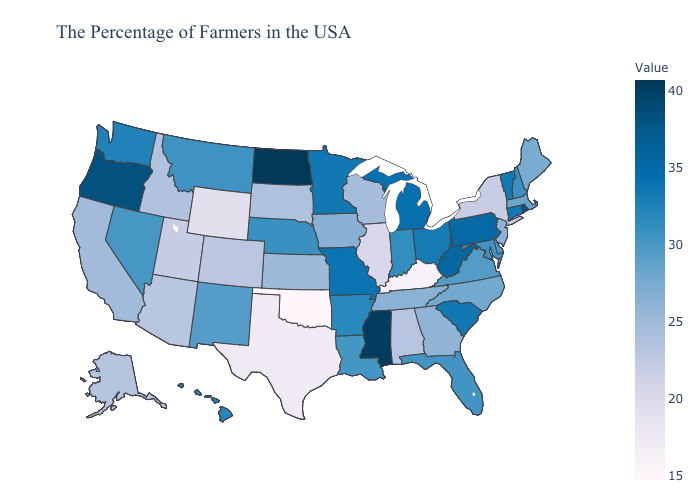Does Maine have the highest value in the Northeast?
Give a very brief answer. No. Among the states that border Kentucky , does Illinois have the lowest value?
Write a very short answer. Yes. Is the legend a continuous bar?
Concise answer only. Yes. Among the states that border Oregon , which have the lowest value?
Answer briefly. Idaho. Which states have the highest value in the USA?
Be succinct. North Dakota. Which states have the lowest value in the South?
Answer briefly. Oklahoma. 